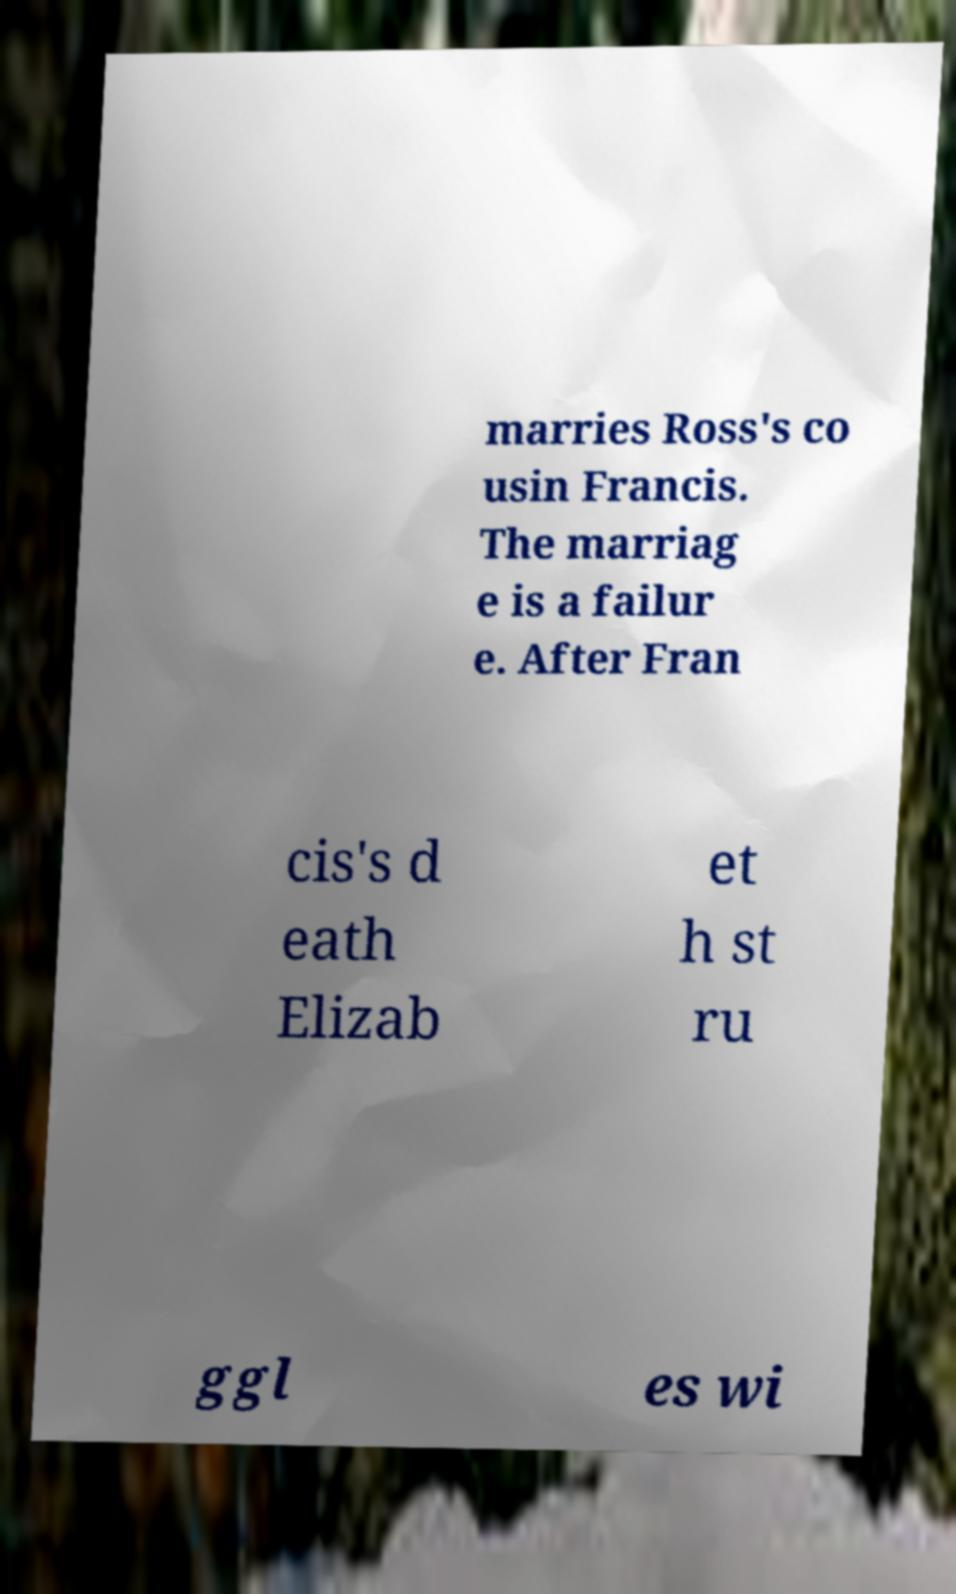Could you extract and type out the text from this image? marries Ross's co usin Francis. The marriag e is a failur e. After Fran cis's d eath Elizab et h st ru ggl es wi 